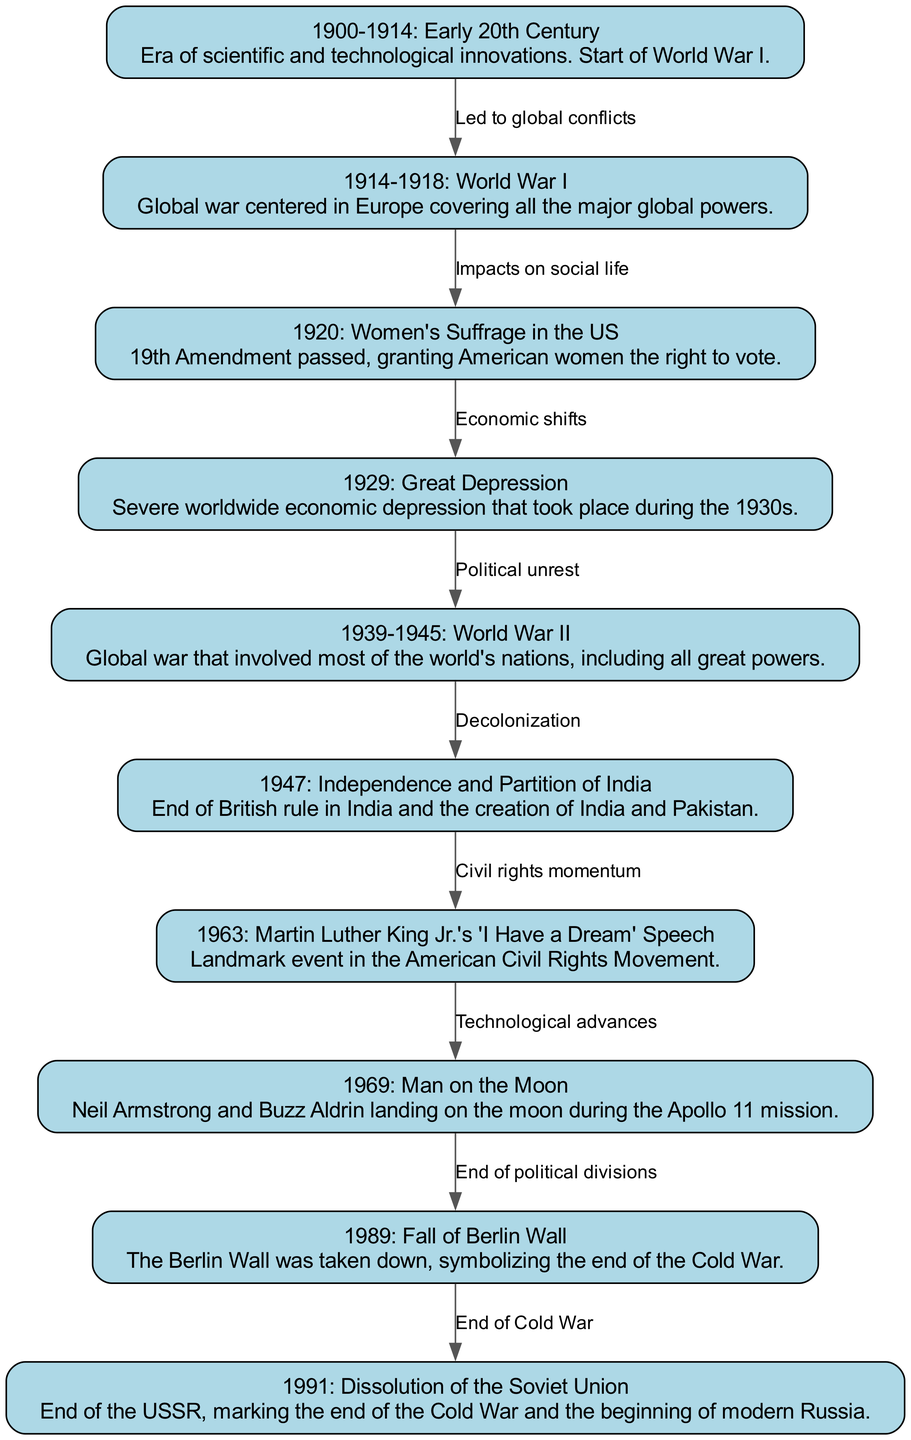What is the first significant event noted in the timeline? The timeline begins with the node labeled "1900-1914: Early 20th Century," which indicates the early period of the 20th century before the larger global conflict of World War I.
Answer: 1900-1914: Early 20th Century How many edges are depicted in the diagram? The diagram features ten edges, each representing a relationship or flow between the nodes that correspond to important historical events.
Answer: 10 What event occurred immediately after World War I? Following World War I, the timeline presents a significant social change with the passage of the 19th Amendment, granting women the right to vote in the US, which is represented in the node labeled "1920: Women's Suffrage in the US."
Answer: Women's Suffrage in the US Which event is linked to decolonization? The diagram connects the end of British rule in India and the subsequent creation of India and Pakistan (node 6) to the global conflict of World War II (node 5) as part of the broader theme of decolonization following world conflicts.
Answer: Independence and Partition of India What is the relationship between the fall of the Berlin Wall and the dissolution of the Soviet Union? The relationship is portrayed in the diagram with an edge that indicates the Fall of the Berlin Wall in 1989 (node 9) symbolizing the end of political divisions, which led to the dissolution of the Soviet Union in 1991 (node 10), marking the end of the Cold War.
Answer: End of Cold War What major civil rights event took place in 1963? In 1963, Martin Luther King Jr. delivered his "I Have a Dream" speech, a pivotal moment in the American Civil Rights Movement, represented in the diagram as node 7.
Answer: Martin Luther King Jr.'s 'I Have a Dream' Speech Which two nations were created as a result of the independence of India? The timeline attributes the independence of India (node 6) to the formation of two nations: India and Pakistan, marking a significant geopolitical change in the region.
Answer: India and Pakistan What significant technological achievement occurred in 1969? The timeline highlights the landmark achievement of mankind landing on the moon during the Apollo 11 mission with Neil Armstrong and Buzz Aldrin, represented as node 8 in the diagram.
Answer: Man on the Moon 